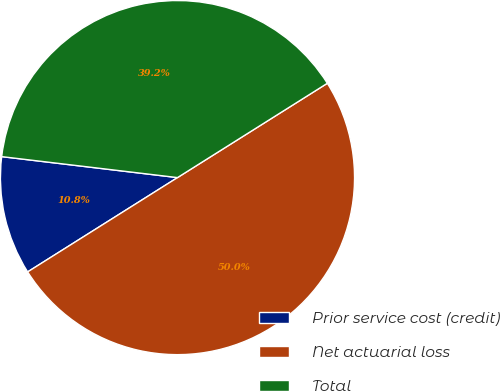Convert chart. <chart><loc_0><loc_0><loc_500><loc_500><pie_chart><fcel>Prior service cost (credit)<fcel>Net actuarial loss<fcel>Total<nl><fcel>10.83%<fcel>50.0%<fcel>39.17%<nl></chart> 